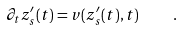Convert formula to latex. <formula><loc_0><loc_0><loc_500><loc_500>\partial _ { t } z ^ { \prime } _ { s } ( t ) = v ( z ^ { \prime } _ { s } ( t ) , t ) \quad .</formula> 